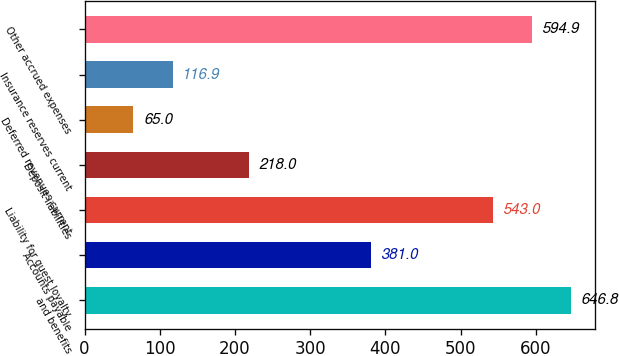Convert chart. <chart><loc_0><loc_0><loc_500><loc_500><bar_chart><fcel>and benefits<fcel>Accounts payable<fcel>Liability for guest loyalty<fcel>Deposit liabilities<fcel>Deferred revenues current<fcel>Insurance reserves current<fcel>Other accrued expenses<nl><fcel>646.8<fcel>381<fcel>543<fcel>218<fcel>65<fcel>116.9<fcel>594.9<nl></chart> 